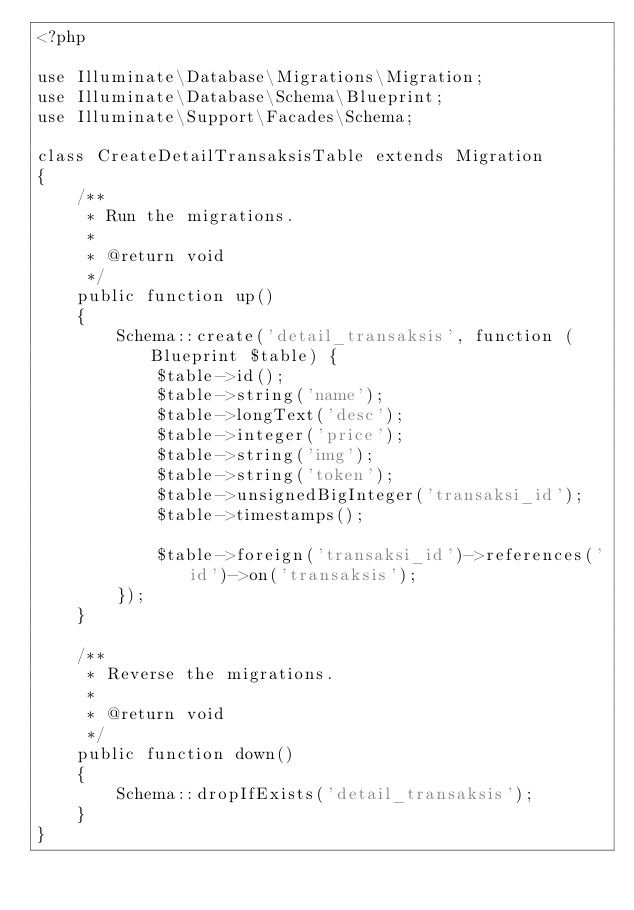<code> <loc_0><loc_0><loc_500><loc_500><_PHP_><?php

use Illuminate\Database\Migrations\Migration;
use Illuminate\Database\Schema\Blueprint;
use Illuminate\Support\Facades\Schema;

class CreateDetailTransaksisTable extends Migration
{
    /**
     * Run the migrations.
     *
     * @return void
     */
    public function up()
    {
        Schema::create('detail_transaksis', function (Blueprint $table) {
            $table->id();
            $table->string('name');
            $table->longText('desc');
            $table->integer('price');
            $table->string('img');
            $table->string('token');
            $table->unsignedBigInteger('transaksi_id');
            $table->timestamps();

            $table->foreign('transaksi_id')->references('id')->on('transaksis');
        });
    }

    /**
     * Reverse the migrations.
     *
     * @return void
     */
    public function down()
    {
        Schema::dropIfExists('detail_transaksis');
    }
}
</code> 